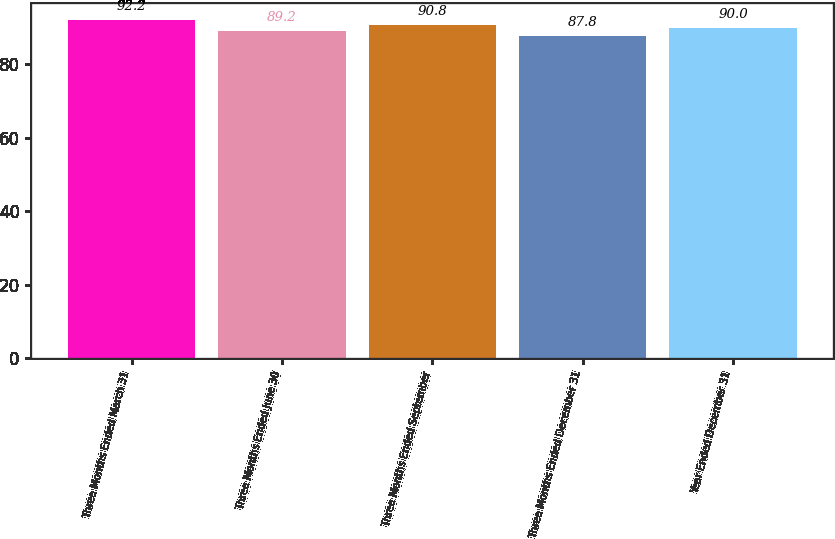Convert chart to OTSL. <chart><loc_0><loc_0><loc_500><loc_500><bar_chart><fcel>Three Months Ended March 31<fcel>Three Months Ended June 30<fcel>Three Months Ended September<fcel>Three Months Ended December 31<fcel>Year Ended December 31<nl><fcel>92.2<fcel>89.2<fcel>90.8<fcel>87.8<fcel>90<nl></chart> 